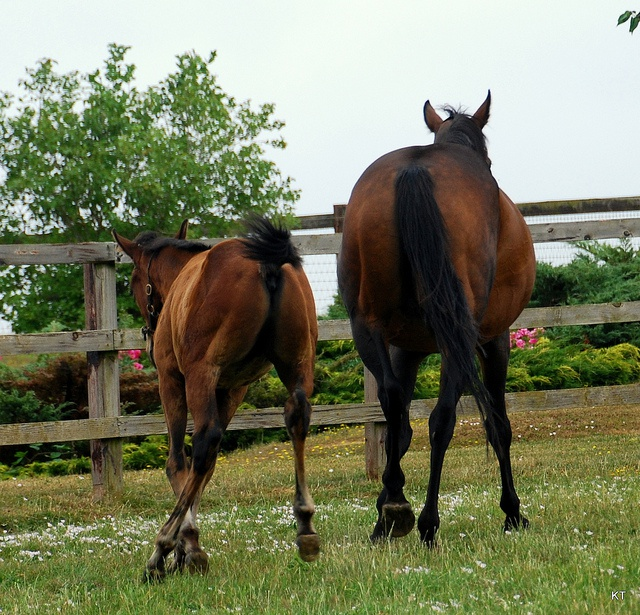Describe the objects in this image and their specific colors. I can see horse in white, black, maroon, and olive tones and horse in white, black, maroon, and brown tones in this image. 